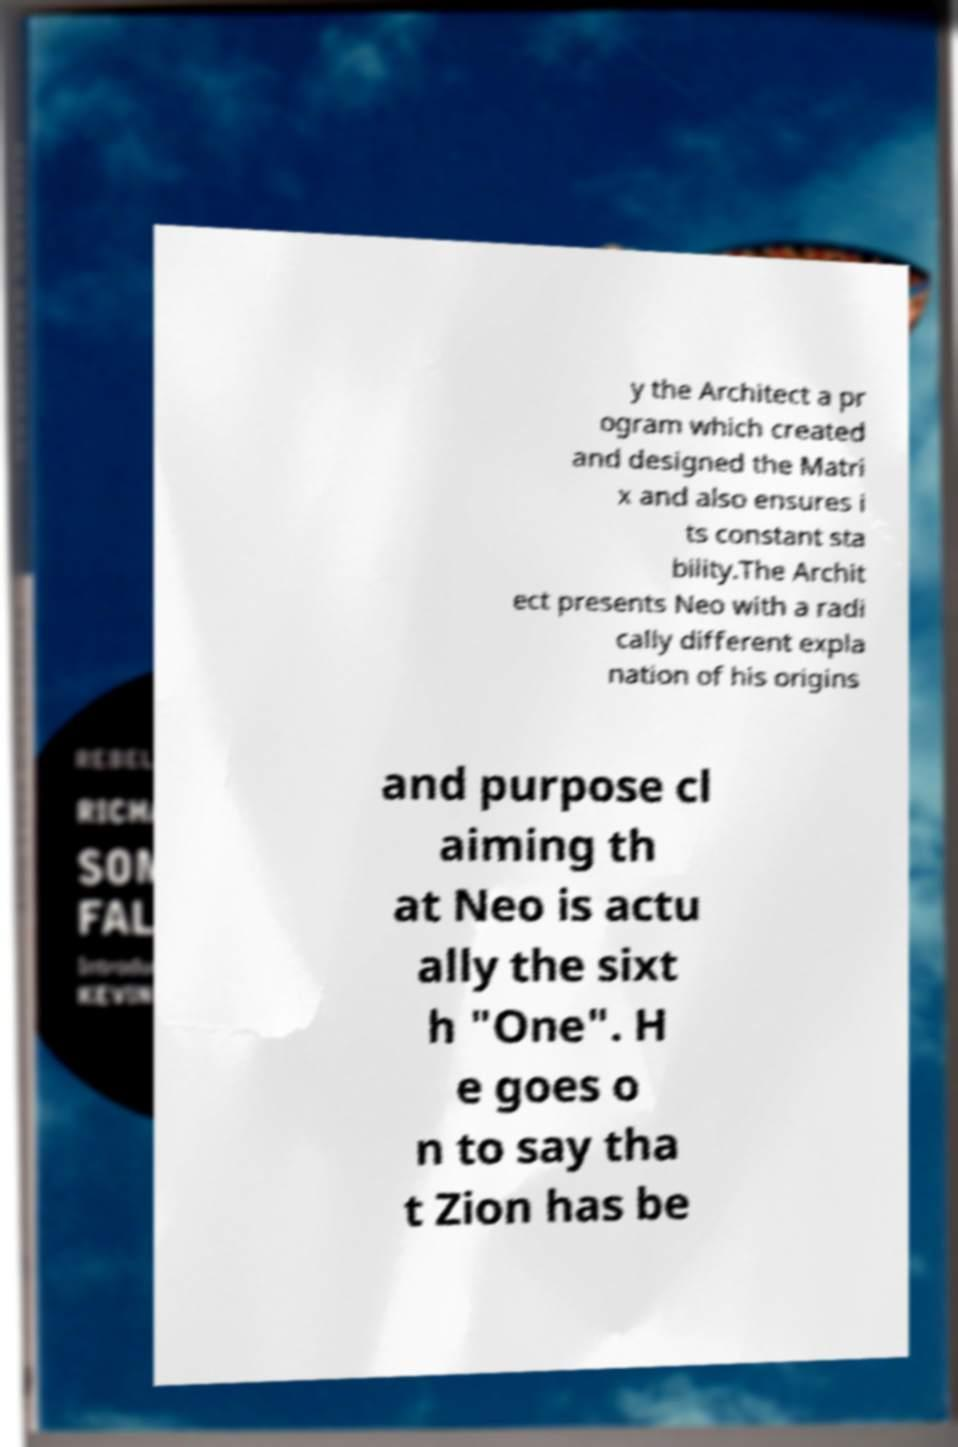Could you assist in decoding the text presented in this image and type it out clearly? y the Architect a pr ogram which created and designed the Matri x and also ensures i ts constant sta bility.The Archit ect presents Neo with a radi cally different expla nation of his origins and purpose cl aiming th at Neo is actu ally the sixt h "One". H e goes o n to say tha t Zion has be 